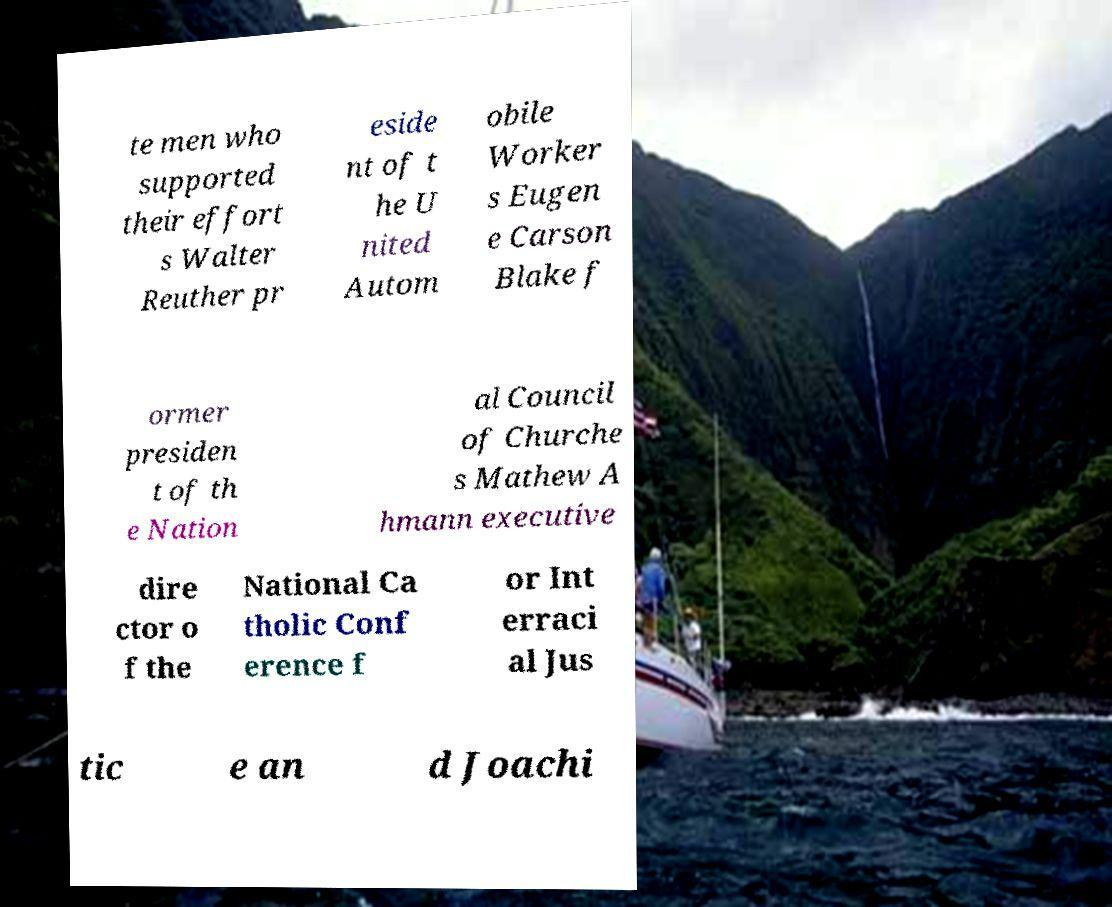Please read and relay the text visible in this image. What does it say? te men who supported their effort s Walter Reuther pr eside nt of t he U nited Autom obile Worker s Eugen e Carson Blake f ormer presiden t of th e Nation al Council of Churche s Mathew A hmann executive dire ctor o f the National Ca tholic Conf erence f or Int erraci al Jus tic e an d Joachi 